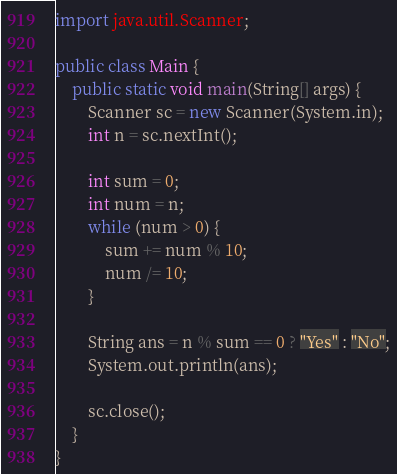Convert code to text. <code><loc_0><loc_0><loc_500><loc_500><_Java_>import java.util.Scanner;

public class Main {
	public static void main(String[] args) {
		Scanner sc = new Scanner(System.in);
		int n = sc.nextInt();
		
		int sum = 0;
		int num = n;
		while (num > 0) {
			sum += num % 10;
			num /= 10;
		}
		
		String ans = n % sum == 0 ? "Yes" : "No";
		System.out.println(ans);
		
		sc.close();
	}
}


</code> 